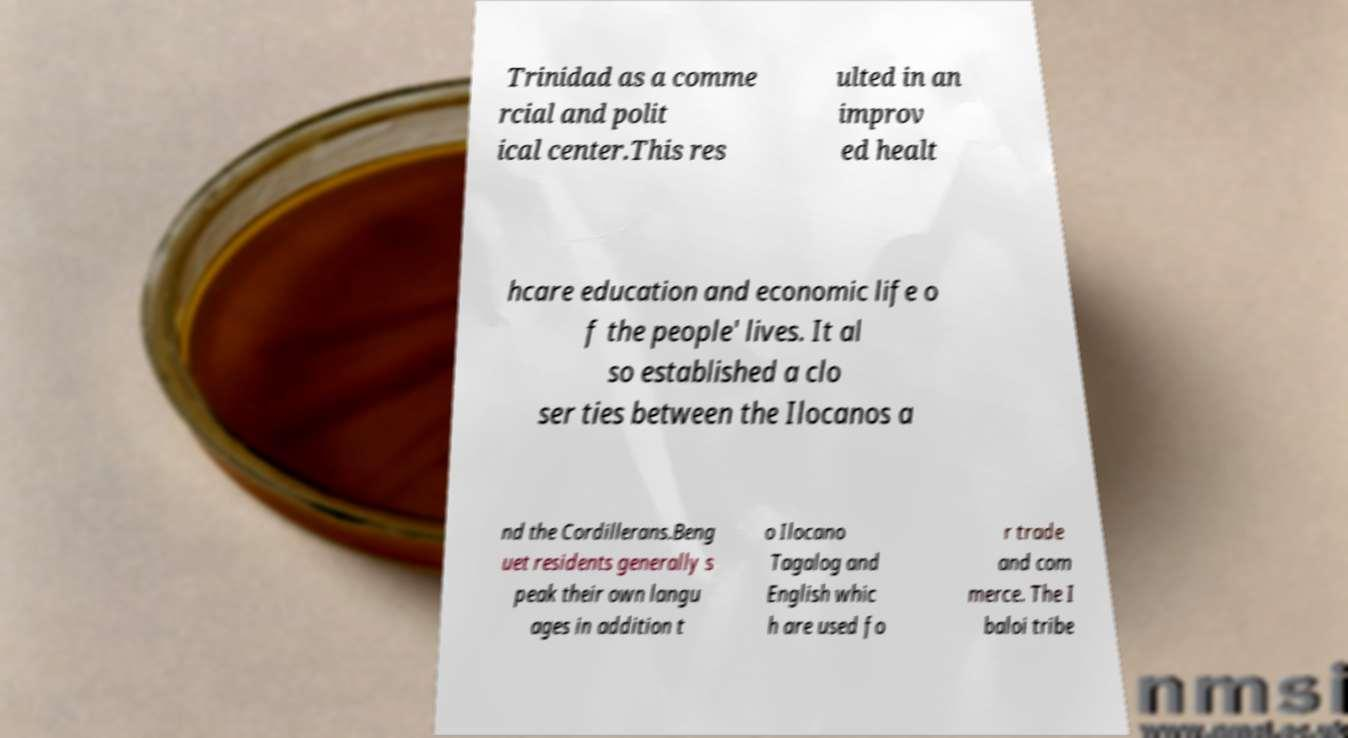What messages or text are displayed in this image? I need them in a readable, typed format. Trinidad as a comme rcial and polit ical center.This res ulted in an improv ed healt hcare education and economic life o f the people' lives. It al so established a clo ser ties between the Ilocanos a nd the Cordillerans.Beng uet residents generally s peak their own langu ages in addition t o Ilocano Tagalog and English whic h are used fo r trade and com merce. The I baloi tribe 